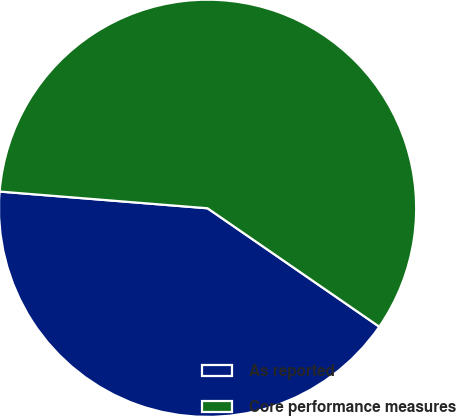<chart> <loc_0><loc_0><loc_500><loc_500><pie_chart><fcel>As reported<fcel>Core performance measures<nl><fcel>41.67%<fcel>58.33%<nl></chart> 